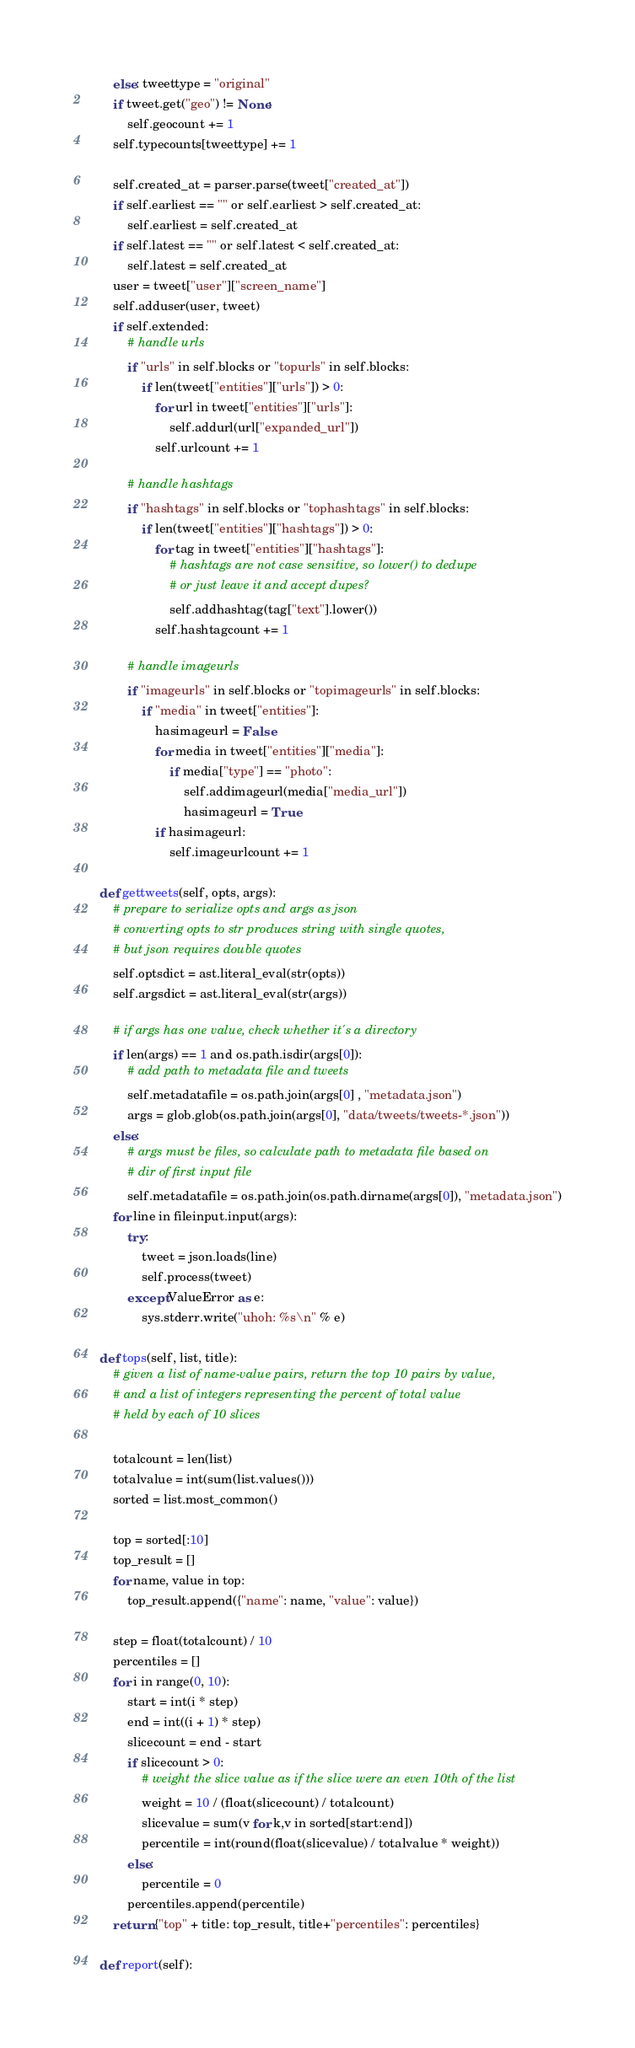<code> <loc_0><loc_0><loc_500><loc_500><_Python_>        else: tweettype = "original"
        if tweet.get("geo") != None:
            self.geocount += 1
        self.typecounts[tweettype] += 1

        self.created_at = parser.parse(tweet["created_at"])
        if self.earliest == "" or self.earliest > self.created_at:
            self.earliest = self.created_at
        if self.latest == "" or self.latest < self.created_at:
            self.latest = self.created_at
        user = tweet["user"]["screen_name"]
        self.adduser(user, tweet)
        if self.extended:
            # handle urls
            if "urls" in self.blocks or "topurls" in self.blocks:
                if len(tweet["entities"]["urls"]) > 0:
                    for url in tweet["entities"]["urls"]:
                        self.addurl(url["expanded_url"])
                    self.urlcount += 1
                
            # handle hashtags
            if "hashtags" in self.blocks or "tophashtags" in self.blocks:
                if len(tweet["entities"]["hashtags"]) > 0:
                    for tag in tweet["entities"]["hashtags"]:
                        # hashtags are not case sensitive, so lower() to dedupe
                        # or just leave it and accept dupes?
                        self.addhashtag(tag["text"].lower())
                    self.hashtagcount += 1
            
            # handle imageurls
            if "imageurls" in self.blocks or "topimageurls" in self.blocks:
                if "media" in tweet["entities"]:
                    hasimageurl = False
                    for media in tweet["entities"]["media"]:
                        if media["type"] == "photo":
                            self.addimageurl(media["media_url"])
                            hasimageurl = True
                    if hasimageurl:
                        self.imageurlcount += 1

    def gettweets(self, opts, args):
        # prepare to serialize opts and args as json
        # converting opts to str produces string with single quotes,
        # but json requires double quotes
        self.optsdict = ast.literal_eval(str(opts))
        self.argsdict = ast.literal_eval(str(args))

        # if args has one value, check whether it's a directory
        if len(args) == 1 and os.path.isdir(args[0]):
            # add path to metadata file and tweets
            self.metadatafile = os.path.join(args[0] , "metadata.json")
            args = glob.glob(os.path.join(args[0], "data/tweets/tweets-*.json"))
        else:
            # args must be files, so calculate path to metadata file based on 
            # dir of first input file
            self.metadatafile = os.path.join(os.path.dirname(args[0]), "metadata.json")
        for line in fileinput.input(args):
            try:
                tweet = json.loads(line)
                self.process(tweet)
            except ValueError as e:
                sys.stderr.write("uhoh: %s\n" % e)
     
    def tops(self, list, title):
        # given a list of name-value pairs, return the top 10 pairs by value,
        # and a list of integers representing the percent of total value
        # held by each of 10 slices
        
        totalcount = len(list)
        totalvalue = int(sum(list.values()))
        sorted = list.most_common()
        
        top = sorted[:10]
        top_result = []
        for name, value in top:
            top_result.append({"name": name, "value": value})

        step = float(totalcount) / 10
        percentiles = []
        for i in range(0, 10):
            start = int(i * step)
            end = int((i + 1) * step)
            slicecount = end - start
            if slicecount > 0:
                # weight the slice value as if the slice were an even 10th of the list
                weight = 10 / (float(slicecount) / totalcount)
                slicevalue = sum(v for k,v in sorted[start:end])
                percentile = int(round(float(slicevalue) / totalvalue * weight))
            else:
                percentile = 0
            percentiles.append(percentile)
        return {"top" + title: top_result, title+"percentiles": percentiles}
    
    def report(self):</code> 